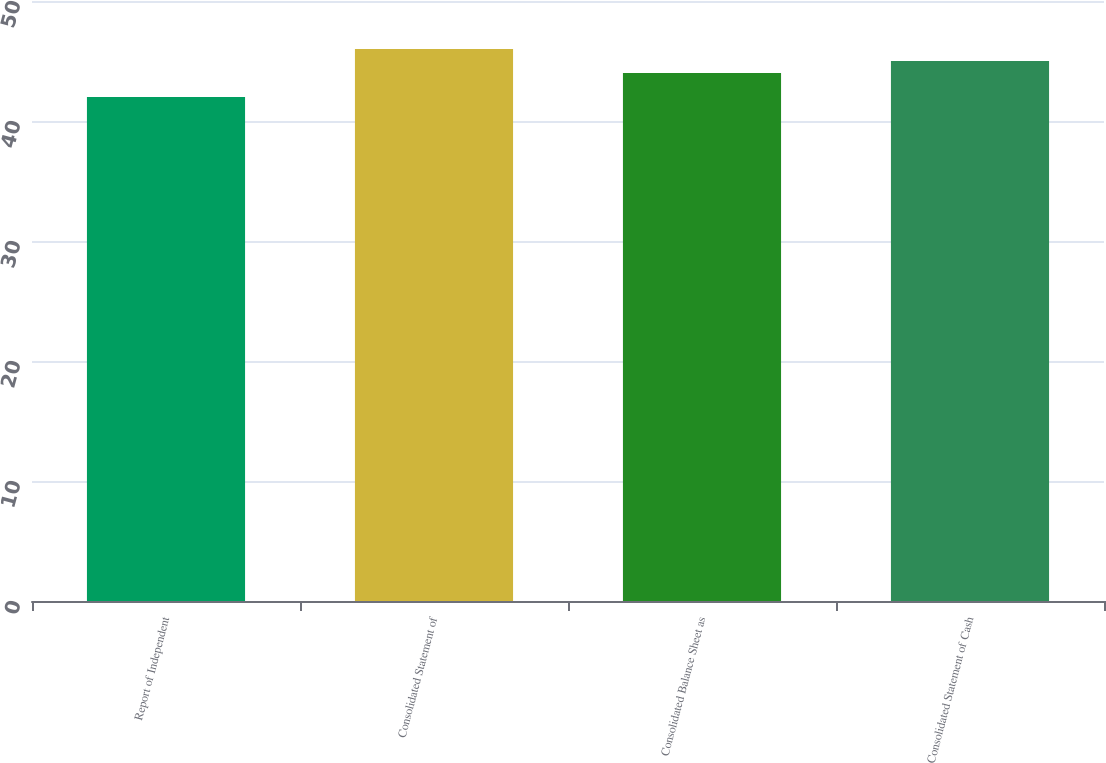Convert chart to OTSL. <chart><loc_0><loc_0><loc_500><loc_500><bar_chart><fcel>Report of Independent<fcel>Consolidated Statement of<fcel>Consolidated Balance Sheet as<fcel>Consolidated Statement of Cash<nl><fcel>42<fcel>46<fcel>44<fcel>45<nl></chart> 